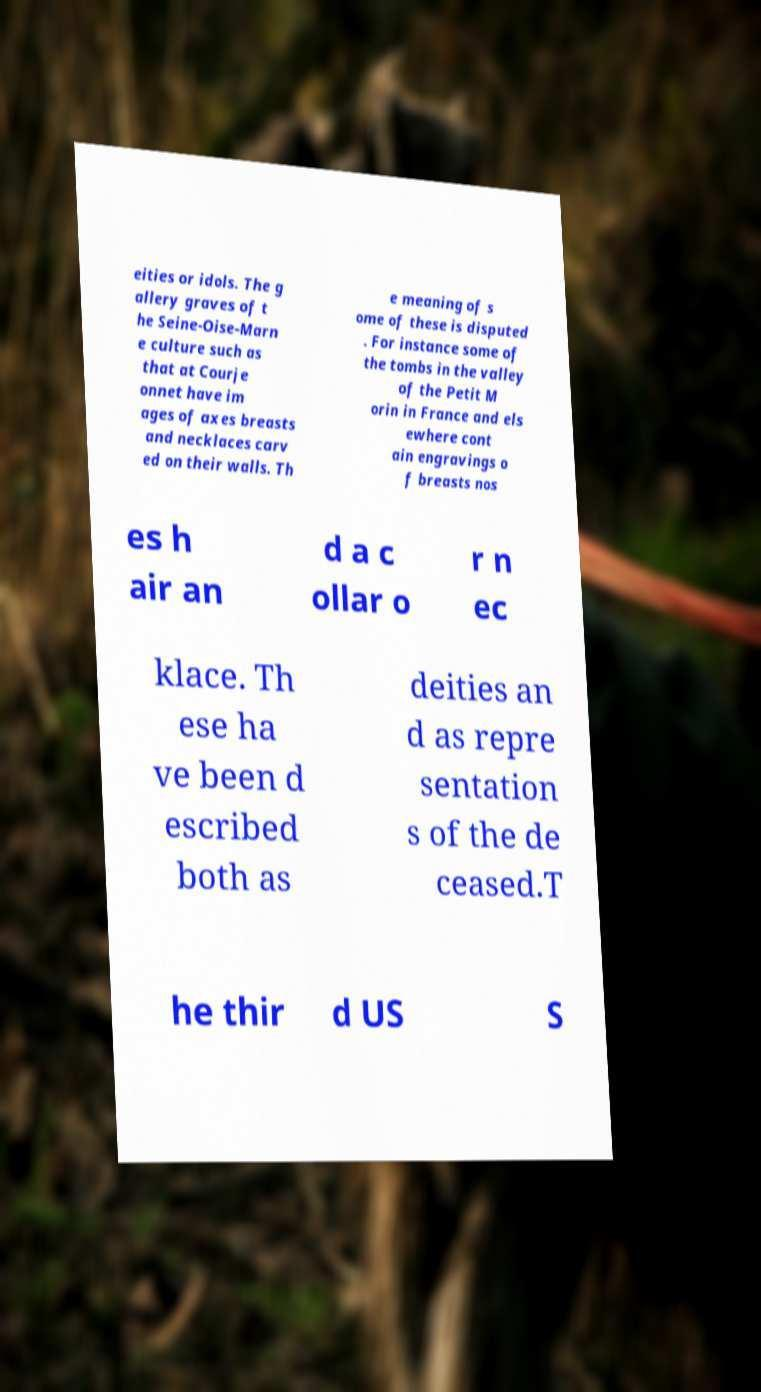Could you assist in decoding the text presented in this image and type it out clearly? eities or idols. The g allery graves of t he Seine-Oise-Marn e culture such as that at Courje onnet have im ages of axes breasts and necklaces carv ed on their walls. Th e meaning of s ome of these is disputed . For instance some of the tombs in the valley of the Petit M orin in France and els ewhere cont ain engravings o f breasts nos es h air an d a c ollar o r n ec klace. Th ese ha ve been d escribed both as deities an d as repre sentation s of the de ceased.T he thir d US S 